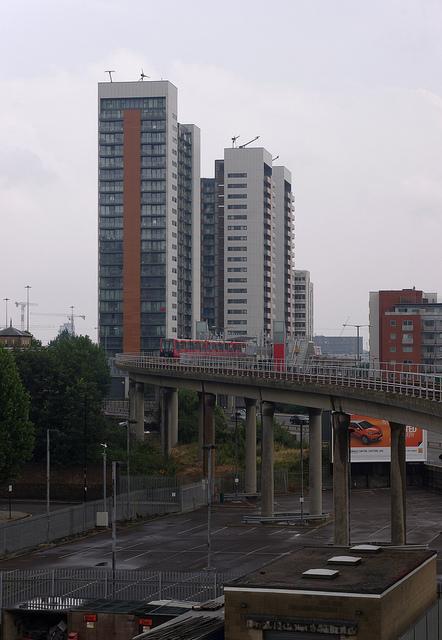Are people standing on the bridge?
Answer briefly. No. Are all the roofs flat?
Short answer required. Yes. How many buildings are depicted in the picture?
Write a very short answer. 4. Is there water on the cement?
Short answer required. Yes. What is under the bridge?
Quick response, please. Parking lot. Is the parking area full?
Be succinct. No. Could this be a marina?
Write a very short answer. No. 